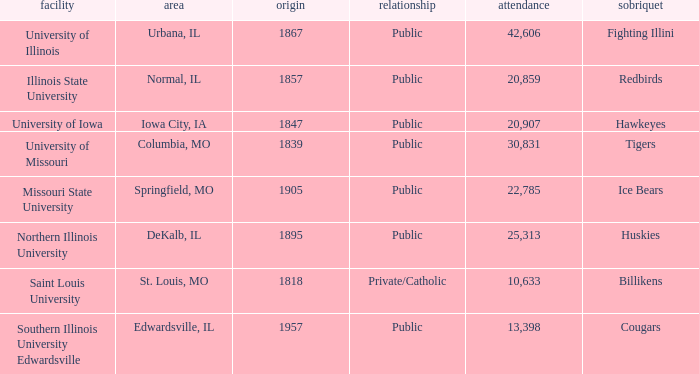What is Southern Illinois University Edwardsville's affiliation? Public. 